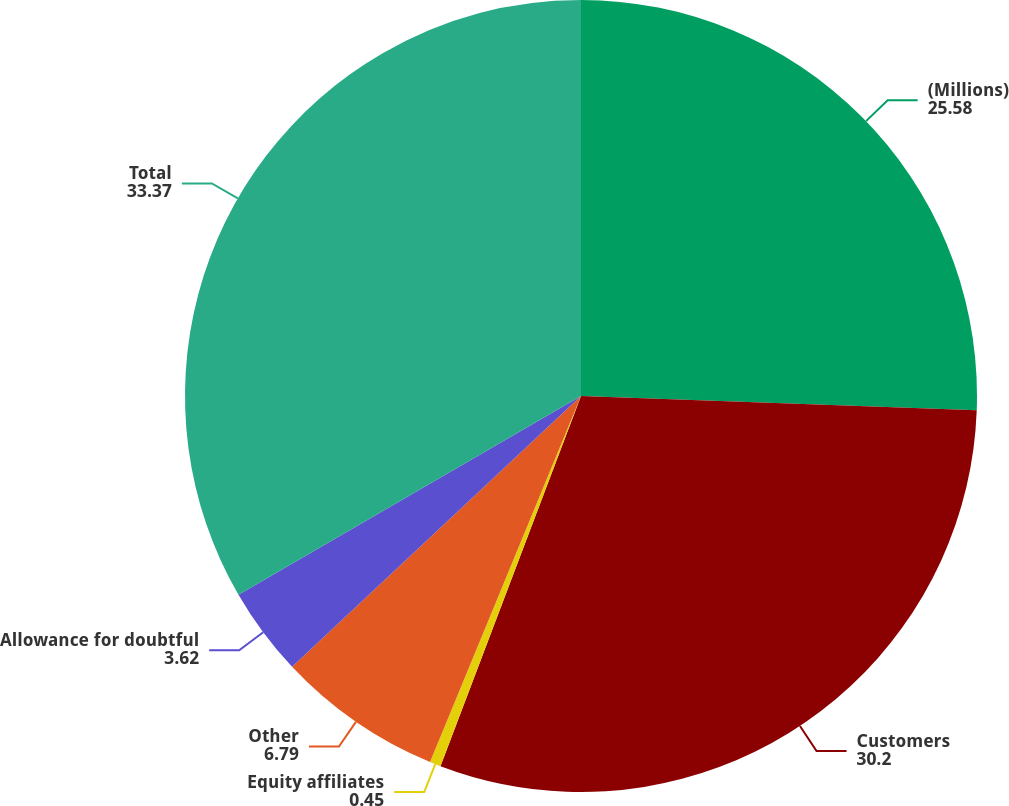Convert chart. <chart><loc_0><loc_0><loc_500><loc_500><pie_chart><fcel>(Millions)<fcel>Customers<fcel>Equity affiliates<fcel>Other<fcel>Allowance for doubtful<fcel>Total<nl><fcel>25.58%<fcel>30.2%<fcel>0.45%<fcel>6.79%<fcel>3.62%<fcel>33.37%<nl></chart> 